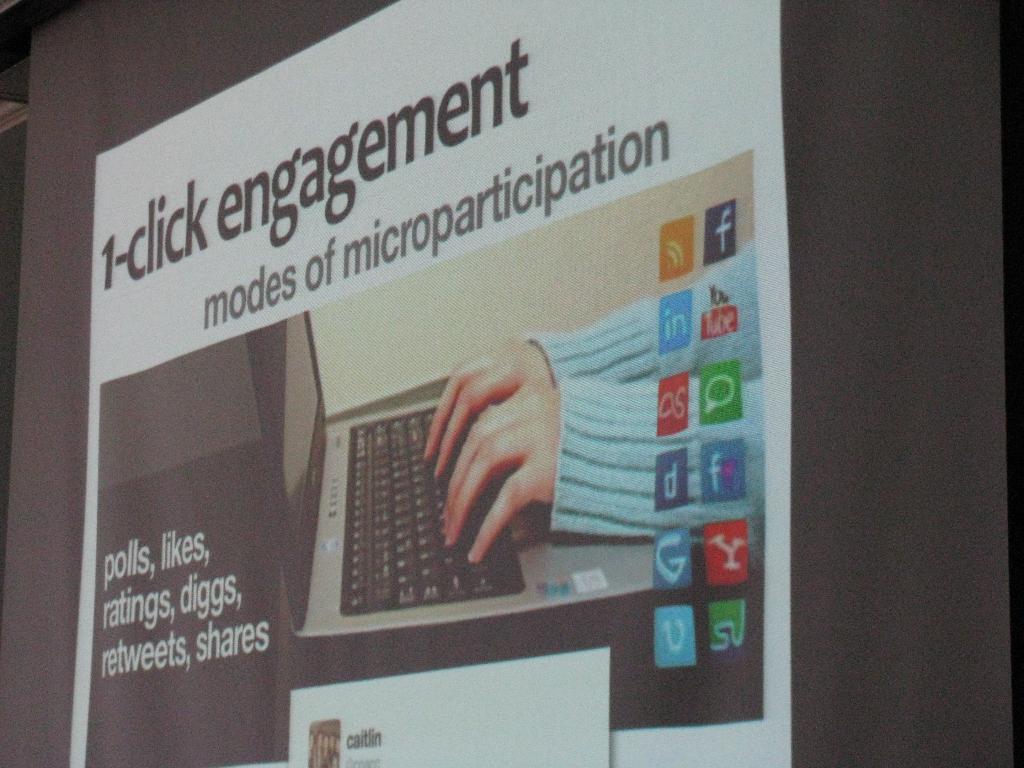What is the title of this?
Your response must be concise. 1-click engagement. What is microparticipation?
Provide a short and direct response. 1-click engagement. 